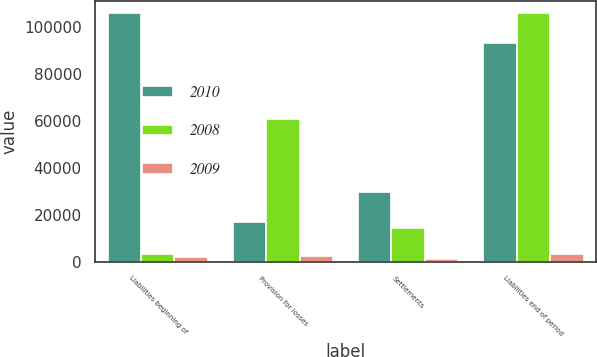<chart> <loc_0><loc_0><loc_500><loc_500><stacked_bar_chart><ecel><fcel>Liabilities beginning of<fcel>Provision for losses<fcel>Settlements<fcel>Liabilities end of period<nl><fcel>2010<fcel>105914<fcel>16856<fcel>29713<fcel>93057<nl><fcel>2008<fcel>3240<fcel>60896<fcel>14515<fcel>105914<nl><fcel>2009<fcel>2107<fcel>2370<fcel>1237<fcel>3240<nl></chart> 